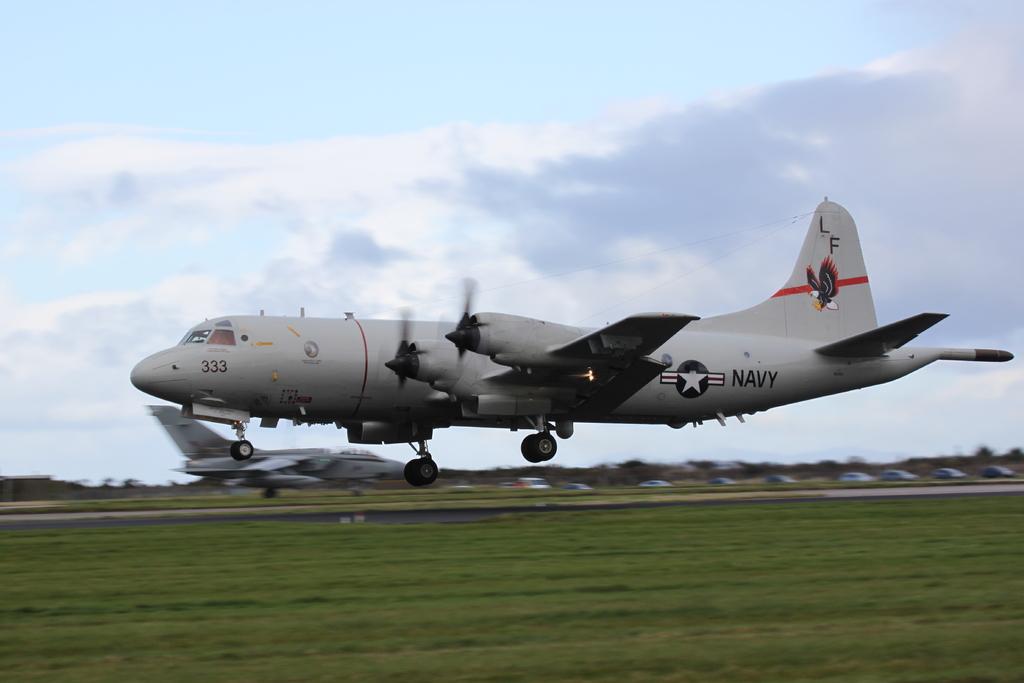What kind of plane is this?
Offer a very short reply. Navy. 